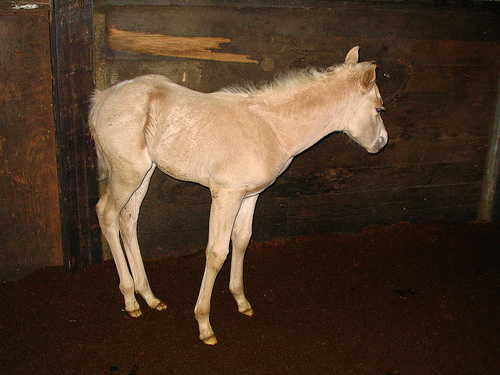<image>
Is there a donkey to the left of the floor? No. The donkey is not to the left of the floor. From this viewpoint, they have a different horizontal relationship. 